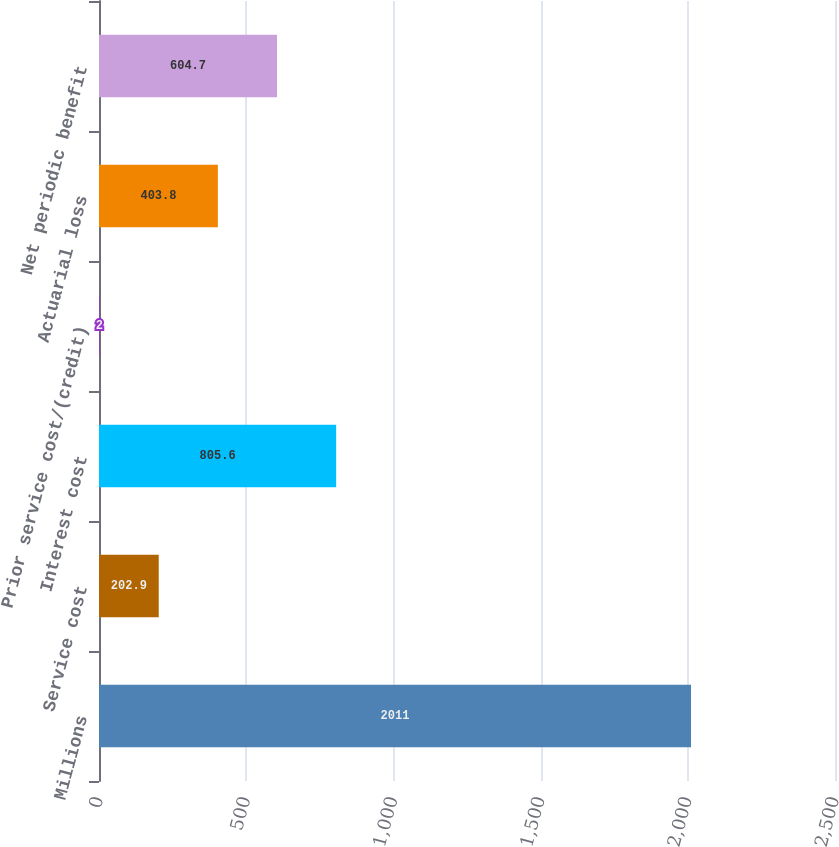Convert chart to OTSL. <chart><loc_0><loc_0><loc_500><loc_500><bar_chart><fcel>Millions<fcel>Service cost<fcel>Interest cost<fcel>Prior service cost/(credit)<fcel>Actuarial loss<fcel>Net periodic benefit<nl><fcel>2011<fcel>202.9<fcel>805.6<fcel>2<fcel>403.8<fcel>604.7<nl></chart> 